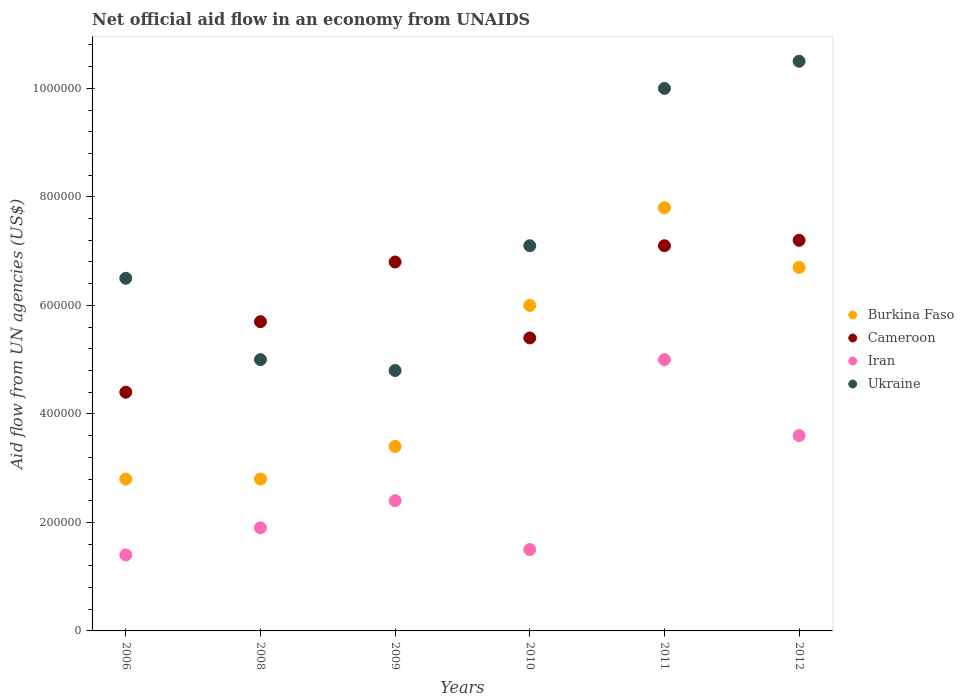Is the number of dotlines equal to the number of legend labels?
Your response must be concise. Yes. Across all years, what is the maximum net official aid flow in Iran?
Offer a terse response. 5.00e+05. Across all years, what is the minimum net official aid flow in Burkina Faso?
Provide a succinct answer. 2.80e+05. In which year was the net official aid flow in Ukraine minimum?
Your answer should be compact. 2009. What is the total net official aid flow in Ukraine in the graph?
Your answer should be compact. 4.39e+06. What is the difference between the net official aid flow in Cameroon in 2006 and that in 2011?
Offer a terse response. -2.70e+05. What is the difference between the net official aid flow in Iran in 2010 and the net official aid flow in Cameroon in 2009?
Your answer should be very brief. -5.30e+05. What is the average net official aid flow in Iran per year?
Provide a short and direct response. 2.63e+05. In the year 2012, what is the difference between the net official aid flow in Burkina Faso and net official aid flow in Ukraine?
Keep it short and to the point. -3.80e+05. In how many years, is the net official aid flow in Burkina Faso greater than 720000 US$?
Give a very brief answer. 1. What is the ratio of the net official aid flow in Iran in 2009 to that in 2011?
Ensure brevity in your answer.  0.48. Is the net official aid flow in Iran in 2009 less than that in 2012?
Your response must be concise. Yes. What is the difference between the highest and the second highest net official aid flow in Ukraine?
Provide a short and direct response. 5.00e+04. What is the difference between the highest and the lowest net official aid flow in Burkina Faso?
Offer a very short reply. 5.00e+05. In how many years, is the net official aid flow in Iran greater than the average net official aid flow in Iran taken over all years?
Your answer should be compact. 2. Is the sum of the net official aid flow in Burkina Faso in 2008 and 2009 greater than the maximum net official aid flow in Iran across all years?
Give a very brief answer. Yes. Is it the case that in every year, the sum of the net official aid flow in Ukraine and net official aid flow in Burkina Faso  is greater than the net official aid flow in Iran?
Your answer should be compact. Yes. Is the net official aid flow in Burkina Faso strictly greater than the net official aid flow in Ukraine over the years?
Your answer should be compact. No. Is the net official aid flow in Iran strictly less than the net official aid flow in Ukraine over the years?
Provide a succinct answer. Yes. How many dotlines are there?
Provide a short and direct response. 4. Are the values on the major ticks of Y-axis written in scientific E-notation?
Offer a terse response. No. Does the graph contain any zero values?
Provide a succinct answer. No. Does the graph contain grids?
Your answer should be compact. No. How many legend labels are there?
Ensure brevity in your answer.  4. How are the legend labels stacked?
Ensure brevity in your answer.  Vertical. What is the title of the graph?
Give a very brief answer. Net official aid flow in an economy from UNAIDS. What is the label or title of the Y-axis?
Offer a very short reply. Aid flow from UN agencies (US$). What is the Aid flow from UN agencies (US$) in Cameroon in 2006?
Offer a terse response. 4.40e+05. What is the Aid flow from UN agencies (US$) in Ukraine in 2006?
Your answer should be very brief. 6.50e+05. What is the Aid flow from UN agencies (US$) of Burkina Faso in 2008?
Offer a very short reply. 2.80e+05. What is the Aid flow from UN agencies (US$) in Cameroon in 2008?
Provide a short and direct response. 5.70e+05. What is the Aid flow from UN agencies (US$) of Ukraine in 2008?
Offer a very short reply. 5.00e+05. What is the Aid flow from UN agencies (US$) of Burkina Faso in 2009?
Offer a very short reply. 3.40e+05. What is the Aid flow from UN agencies (US$) of Cameroon in 2009?
Provide a succinct answer. 6.80e+05. What is the Aid flow from UN agencies (US$) of Iran in 2009?
Your response must be concise. 2.40e+05. What is the Aid flow from UN agencies (US$) in Ukraine in 2009?
Offer a terse response. 4.80e+05. What is the Aid flow from UN agencies (US$) of Cameroon in 2010?
Your response must be concise. 5.40e+05. What is the Aid flow from UN agencies (US$) of Ukraine in 2010?
Ensure brevity in your answer.  7.10e+05. What is the Aid flow from UN agencies (US$) of Burkina Faso in 2011?
Make the answer very short. 7.80e+05. What is the Aid flow from UN agencies (US$) of Cameroon in 2011?
Ensure brevity in your answer.  7.10e+05. What is the Aid flow from UN agencies (US$) in Iran in 2011?
Keep it short and to the point. 5.00e+05. What is the Aid flow from UN agencies (US$) of Ukraine in 2011?
Offer a very short reply. 1.00e+06. What is the Aid flow from UN agencies (US$) in Burkina Faso in 2012?
Offer a terse response. 6.70e+05. What is the Aid flow from UN agencies (US$) in Cameroon in 2012?
Provide a succinct answer. 7.20e+05. What is the Aid flow from UN agencies (US$) in Ukraine in 2012?
Provide a succinct answer. 1.05e+06. Across all years, what is the maximum Aid flow from UN agencies (US$) in Burkina Faso?
Your response must be concise. 7.80e+05. Across all years, what is the maximum Aid flow from UN agencies (US$) of Cameroon?
Your answer should be very brief. 7.20e+05. Across all years, what is the maximum Aid flow from UN agencies (US$) in Ukraine?
Ensure brevity in your answer.  1.05e+06. Across all years, what is the minimum Aid flow from UN agencies (US$) of Iran?
Offer a terse response. 1.40e+05. Across all years, what is the minimum Aid flow from UN agencies (US$) in Ukraine?
Offer a terse response. 4.80e+05. What is the total Aid flow from UN agencies (US$) of Burkina Faso in the graph?
Provide a succinct answer. 2.95e+06. What is the total Aid flow from UN agencies (US$) of Cameroon in the graph?
Offer a very short reply. 3.66e+06. What is the total Aid flow from UN agencies (US$) in Iran in the graph?
Offer a very short reply. 1.58e+06. What is the total Aid flow from UN agencies (US$) in Ukraine in the graph?
Your answer should be compact. 4.39e+06. What is the difference between the Aid flow from UN agencies (US$) of Burkina Faso in 2006 and that in 2008?
Offer a terse response. 0. What is the difference between the Aid flow from UN agencies (US$) in Cameroon in 2006 and that in 2008?
Offer a terse response. -1.30e+05. What is the difference between the Aid flow from UN agencies (US$) of Ukraine in 2006 and that in 2008?
Ensure brevity in your answer.  1.50e+05. What is the difference between the Aid flow from UN agencies (US$) of Burkina Faso in 2006 and that in 2009?
Your response must be concise. -6.00e+04. What is the difference between the Aid flow from UN agencies (US$) of Burkina Faso in 2006 and that in 2010?
Your answer should be very brief. -3.20e+05. What is the difference between the Aid flow from UN agencies (US$) of Cameroon in 2006 and that in 2010?
Offer a terse response. -1.00e+05. What is the difference between the Aid flow from UN agencies (US$) in Iran in 2006 and that in 2010?
Offer a terse response. -10000. What is the difference between the Aid flow from UN agencies (US$) in Burkina Faso in 2006 and that in 2011?
Make the answer very short. -5.00e+05. What is the difference between the Aid flow from UN agencies (US$) of Iran in 2006 and that in 2011?
Your answer should be very brief. -3.60e+05. What is the difference between the Aid flow from UN agencies (US$) of Ukraine in 2006 and that in 2011?
Give a very brief answer. -3.50e+05. What is the difference between the Aid flow from UN agencies (US$) of Burkina Faso in 2006 and that in 2012?
Your answer should be compact. -3.90e+05. What is the difference between the Aid flow from UN agencies (US$) in Cameroon in 2006 and that in 2012?
Your answer should be very brief. -2.80e+05. What is the difference between the Aid flow from UN agencies (US$) in Ukraine in 2006 and that in 2012?
Offer a very short reply. -4.00e+05. What is the difference between the Aid flow from UN agencies (US$) of Burkina Faso in 2008 and that in 2009?
Your response must be concise. -6.00e+04. What is the difference between the Aid flow from UN agencies (US$) of Iran in 2008 and that in 2009?
Offer a very short reply. -5.00e+04. What is the difference between the Aid flow from UN agencies (US$) in Burkina Faso in 2008 and that in 2010?
Keep it short and to the point. -3.20e+05. What is the difference between the Aid flow from UN agencies (US$) of Iran in 2008 and that in 2010?
Provide a succinct answer. 4.00e+04. What is the difference between the Aid flow from UN agencies (US$) of Ukraine in 2008 and that in 2010?
Make the answer very short. -2.10e+05. What is the difference between the Aid flow from UN agencies (US$) in Burkina Faso in 2008 and that in 2011?
Your response must be concise. -5.00e+05. What is the difference between the Aid flow from UN agencies (US$) in Cameroon in 2008 and that in 2011?
Make the answer very short. -1.40e+05. What is the difference between the Aid flow from UN agencies (US$) in Iran in 2008 and that in 2011?
Provide a succinct answer. -3.10e+05. What is the difference between the Aid flow from UN agencies (US$) of Ukraine in 2008 and that in 2011?
Give a very brief answer. -5.00e+05. What is the difference between the Aid flow from UN agencies (US$) in Burkina Faso in 2008 and that in 2012?
Provide a short and direct response. -3.90e+05. What is the difference between the Aid flow from UN agencies (US$) in Cameroon in 2008 and that in 2012?
Your answer should be very brief. -1.50e+05. What is the difference between the Aid flow from UN agencies (US$) of Iran in 2008 and that in 2012?
Keep it short and to the point. -1.70e+05. What is the difference between the Aid flow from UN agencies (US$) in Ukraine in 2008 and that in 2012?
Provide a succinct answer. -5.50e+05. What is the difference between the Aid flow from UN agencies (US$) in Burkina Faso in 2009 and that in 2010?
Give a very brief answer. -2.60e+05. What is the difference between the Aid flow from UN agencies (US$) of Cameroon in 2009 and that in 2010?
Keep it short and to the point. 1.40e+05. What is the difference between the Aid flow from UN agencies (US$) in Burkina Faso in 2009 and that in 2011?
Give a very brief answer. -4.40e+05. What is the difference between the Aid flow from UN agencies (US$) in Cameroon in 2009 and that in 2011?
Ensure brevity in your answer.  -3.00e+04. What is the difference between the Aid flow from UN agencies (US$) of Ukraine in 2009 and that in 2011?
Give a very brief answer. -5.20e+05. What is the difference between the Aid flow from UN agencies (US$) in Burkina Faso in 2009 and that in 2012?
Provide a short and direct response. -3.30e+05. What is the difference between the Aid flow from UN agencies (US$) of Iran in 2009 and that in 2012?
Your answer should be very brief. -1.20e+05. What is the difference between the Aid flow from UN agencies (US$) in Ukraine in 2009 and that in 2012?
Keep it short and to the point. -5.70e+05. What is the difference between the Aid flow from UN agencies (US$) of Cameroon in 2010 and that in 2011?
Give a very brief answer. -1.70e+05. What is the difference between the Aid flow from UN agencies (US$) in Iran in 2010 and that in 2011?
Ensure brevity in your answer.  -3.50e+05. What is the difference between the Aid flow from UN agencies (US$) in Burkina Faso in 2010 and that in 2012?
Your answer should be compact. -7.00e+04. What is the difference between the Aid flow from UN agencies (US$) of Ukraine in 2010 and that in 2012?
Offer a very short reply. -3.40e+05. What is the difference between the Aid flow from UN agencies (US$) of Cameroon in 2011 and that in 2012?
Your answer should be very brief. -10000. What is the difference between the Aid flow from UN agencies (US$) in Iran in 2011 and that in 2012?
Provide a succinct answer. 1.40e+05. What is the difference between the Aid flow from UN agencies (US$) in Burkina Faso in 2006 and the Aid flow from UN agencies (US$) in Iran in 2008?
Offer a terse response. 9.00e+04. What is the difference between the Aid flow from UN agencies (US$) of Cameroon in 2006 and the Aid flow from UN agencies (US$) of Iran in 2008?
Offer a terse response. 2.50e+05. What is the difference between the Aid flow from UN agencies (US$) in Cameroon in 2006 and the Aid flow from UN agencies (US$) in Ukraine in 2008?
Offer a terse response. -6.00e+04. What is the difference between the Aid flow from UN agencies (US$) in Iran in 2006 and the Aid flow from UN agencies (US$) in Ukraine in 2008?
Keep it short and to the point. -3.60e+05. What is the difference between the Aid flow from UN agencies (US$) in Burkina Faso in 2006 and the Aid flow from UN agencies (US$) in Cameroon in 2009?
Provide a short and direct response. -4.00e+05. What is the difference between the Aid flow from UN agencies (US$) in Burkina Faso in 2006 and the Aid flow from UN agencies (US$) in Ukraine in 2009?
Offer a terse response. -2.00e+05. What is the difference between the Aid flow from UN agencies (US$) in Cameroon in 2006 and the Aid flow from UN agencies (US$) in Ukraine in 2009?
Provide a succinct answer. -4.00e+04. What is the difference between the Aid flow from UN agencies (US$) of Iran in 2006 and the Aid flow from UN agencies (US$) of Ukraine in 2009?
Provide a succinct answer. -3.40e+05. What is the difference between the Aid flow from UN agencies (US$) in Burkina Faso in 2006 and the Aid flow from UN agencies (US$) in Ukraine in 2010?
Ensure brevity in your answer.  -4.30e+05. What is the difference between the Aid flow from UN agencies (US$) of Cameroon in 2006 and the Aid flow from UN agencies (US$) of Ukraine in 2010?
Offer a very short reply. -2.70e+05. What is the difference between the Aid flow from UN agencies (US$) of Iran in 2006 and the Aid flow from UN agencies (US$) of Ukraine in 2010?
Make the answer very short. -5.70e+05. What is the difference between the Aid flow from UN agencies (US$) of Burkina Faso in 2006 and the Aid flow from UN agencies (US$) of Cameroon in 2011?
Your response must be concise. -4.30e+05. What is the difference between the Aid flow from UN agencies (US$) in Burkina Faso in 2006 and the Aid flow from UN agencies (US$) in Iran in 2011?
Your answer should be compact. -2.20e+05. What is the difference between the Aid flow from UN agencies (US$) of Burkina Faso in 2006 and the Aid flow from UN agencies (US$) of Ukraine in 2011?
Your answer should be very brief. -7.20e+05. What is the difference between the Aid flow from UN agencies (US$) in Cameroon in 2006 and the Aid flow from UN agencies (US$) in Iran in 2011?
Your answer should be very brief. -6.00e+04. What is the difference between the Aid flow from UN agencies (US$) of Cameroon in 2006 and the Aid flow from UN agencies (US$) of Ukraine in 2011?
Keep it short and to the point. -5.60e+05. What is the difference between the Aid flow from UN agencies (US$) of Iran in 2006 and the Aid flow from UN agencies (US$) of Ukraine in 2011?
Provide a succinct answer. -8.60e+05. What is the difference between the Aid flow from UN agencies (US$) in Burkina Faso in 2006 and the Aid flow from UN agencies (US$) in Cameroon in 2012?
Your response must be concise. -4.40e+05. What is the difference between the Aid flow from UN agencies (US$) in Burkina Faso in 2006 and the Aid flow from UN agencies (US$) in Ukraine in 2012?
Provide a short and direct response. -7.70e+05. What is the difference between the Aid flow from UN agencies (US$) in Cameroon in 2006 and the Aid flow from UN agencies (US$) in Iran in 2012?
Your answer should be compact. 8.00e+04. What is the difference between the Aid flow from UN agencies (US$) in Cameroon in 2006 and the Aid flow from UN agencies (US$) in Ukraine in 2012?
Offer a terse response. -6.10e+05. What is the difference between the Aid flow from UN agencies (US$) of Iran in 2006 and the Aid flow from UN agencies (US$) of Ukraine in 2012?
Provide a succinct answer. -9.10e+05. What is the difference between the Aid flow from UN agencies (US$) of Burkina Faso in 2008 and the Aid flow from UN agencies (US$) of Cameroon in 2009?
Offer a very short reply. -4.00e+05. What is the difference between the Aid flow from UN agencies (US$) in Burkina Faso in 2008 and the Aid flow from UN agencies (US$) in Ukraine in 2009?
Provide a short and direct response. -2.00e+05. What is the difference between the Aid flow from UN agencies (US$) of Cameroon in 2008 and the Aid flow from UN agencies (US$) of Ukraine in 2009?
Provide a succinct answer. 9.00e+04. What is the difference between the Aid flow from UN agencies (US$) of Burkina Faso in 2008 and the Aid flow from UN agencies (US$) of Ukraine in 2010?
Your response must be concise. -4.30e+05. What is the difference between the Aid flow from UN agencies (US$) of Iran in 2008 and the Aid flow from UN agencies (US$) of Ukraine in 2010?
Your answer should be compact. -5.20e+05. What is the difference between the Aid flow from UN agencies (US$) in Burkina Faso in 2008 and the Aid flow from UN agencies (US$) in Cameroon in 2011?
Your answer should be compact. -4.30e+05. What is the difference between the Aid flow from UN agencies (US$) of Burkina Faso in 2008 and the Aid flow from UN agencies (US$) of Iran in 2011?
Give a very brief answer. -2.20e+05. What is the difference between the Aid flow from UN agencies (US$) in Burkina Faso in 2008 and the Aid flow from UN agencies (US$) in Ukraine in 2011?
Your response must be concise. -7.20e+05. What is the difference between the Aid flow from UN agencies (US$) of Cameroon in 2008 and the Aid flow from UN agencies (US$) of Iran in 2011?
Offer a terse response. 7.00e+04. What is the difference between the Aid flow from UN agencies (US$) of Cameroon in 2008 and the Aid flow from UN agencies (US$) of Ukraine in 2011?
Your response must be concise. -4.30e+05. What is the difference between the Aid flow from UN agencies (US$) in Iran in 2008 and the Aid flow from UN agencies (US$) in Ukraine in 2011?
Ensure brevity in your answer.  -8.10e+05. What is the difference between the Aid flow from UN agencies (US$) of Burkina Faso in 2008 and the Aid flow from UN agencies (US$) of Cameroon in 2012?
Make the answer very short. -4.40e+05. What is the difference between the Aid flow from UN agencies (US$) in Burkina Faso in 2008 and the Aid flow from UN agencies (US$) in Ukraine in 2012?
Ensure brevity in your answer.  -7.70e+05. What is the difference between the Aid flow from UN agencies (US$) in Cameroon in 2008 and the Aid flow from UN agencies (US$) in Ukraine in 2012?
Provide a short and direct response. -4.80e+05. What is the difference between the Aid flow from UN agencies (US$) of Iran in 2008 and the Aid flow from UN agencies (US$) of Ukraine in 2012?
Keep it short and to the point. -8.60e+05. What is the difference between the Aid flow from UN agencies (US$) of Burkina Faso in 2009 and the Aid flow from UN agencies (US$) of Cameroon in 2010?
Your answer should be very brief. -2.00e+05. What is the difference between the Aid flow from UN agencies (US$) of Burkina Faso in 2009 and the Aid flow from UN agencies (US$) of Iran in 2010?
Give a very brief answer. 1.90e+05. What is the difference between the Aid flow from UN agencies (US$) in Burkina Faso in 2009 and the Aid flow from UN agencies (US$) in Ukraine in 2010?
Your answer should be compact. -3.70e+05. What is the difference between the Aid flow from UN agencies (US$) in Cameroon in 2009 and the Aid flow from UN agencies (US$) in Iran in 2010?
Give a very brief answer. 5.30e+05. What is the difference between the Aid flow from UN agencies (US$) of Iran in 2009 and the Aid flow from UN agencies (US$) of Ukraine in 2010?
Ensure brevity in your answer.  -4.70e+05. What is the difference between the Aid flow from UN agencies (US$) of Burkina Faso in 2009 and the Aid flow from UN agencies (US$) of Cameroon in 2011?
Offer a very short reply. -3.70e+05. What is the difference between the Aid flow from UN agencies (US$) in Burkina Faso in 2009 and the Aid flow from UN agencies (US$) in Iran in 2011?
Your answer should be compact. -1.60e+05. What is the difference between the Aid flow from UN agencies (US$) of Burkina Faso in 2009 and the Aid flow from UN agencies (US$) of Ukraine in 2011?
Your answer should be very brief. -6.60e+05. What is the difference between the Aid flow from UN agencies (US$) of Cameroon in 2009 and the Aid flow from UN agencies (US$) of Ukraine in 2011?
Ensure brevity in your answer.  -3.20e+05. What is the difference between the Aid flow from UN agencies (US$) of Iran in 2009 and the Aid flow from UN agencies (US$) of Ukraine in 2011?
Provide a succinct answer. -7.60e+05. What is the difference between the Aid flow from UN agencies (US$) of Burkina Faso in 2009 and the Aid flow from UN agencies (US$) of Cameroon in 2012?
Provide a succinct answer. -3.80e+05. What is the difference between the Aid flow from UN agencies (US$) of Burkina Faso in 2009 and the Aid flow from UN agencies (US$) of Ukraine in 2012?
Your answer should be very brief. -7.10e+05. What is the difference between the Aid flow from UN agencies (US$) in Cameroon in 2009 and the Aid flow from UN agencies (US$) in Iran in 2012?
Ensure brevity in your answer.  3.20e+05. What is the difference between the Aid flow from UN agencies (US$) of Cameroon in 2009 and the Aid flow from UN agencies (US$) of Ukraine in 2012?
Offer a terse response. -3.70e+05. What is the difference between the Aid flow from UN agencies (US$) of Iran in 2009 and the Aid flow from UN agencies (US$) of Ukraine in 2012?
Provide a short and direct response. -8.10e+05. What is the difference between the Aid flow from UN agencies (US$) of Burkina Faso in 2010 and the Aid flow from UN agencies (US$) of Ukraine in 2011?
Offer a very short reply. -4.00e+05. What is the difference between the Aid flow from UN agencies (US$) in Cameroon in 2010 and the Aid flow from UN agencies (US$) in Iran in 2011?
Ensure brevity in your answer.  4.00e+04. What is the difference between the Aid flow from UN agencies (US$) in Cameroon in 2010 and the Aid flow from UN agencies (US$) in Ukraine in 2011?
Provide a succinct answer. -4.60e+05. What is the difference between the Aid flow from UN agencies (US$) of Iran in 2010 and the Aid flow from UN agencies (US$) of Ukraine in 2011?
Offer a very short reply. -8.50e+05. What is the difference between the Aid flow from UN agencies (US$) of Burkina Faso in 2010 and the Aid flow from UN agencies (US$) of Cameroon in 2012?
Your response must be concise. -1.20e+05. What is the difference between the Aid flow from UN agencies (US$) in Burkina Faso in 2010 and the Aid flow from UN agencies (US$) in Ukraine in 2012?
Your response must be concise. -4.50e+05. What is the difference between the Aid flow from UN agencies (US$) in Cameroon in 2010 and the Aid flow from UN agencies (US$) in Iran in 2012?
Offer a terse response. 1.80e+05. What is the difference between the Aid flow from UN agencies (US$) in Cameroon in 2010 and the Aid flow from UN agencies (US$) in Ukraine in 2012?
Keep it short and to the point. -5.10e+05. What is the difference between the Aid flow from UN agencies (US$) in Iran in 2010 and the Aid flow from UN agencies (US$) in Ukraine in 2012?
Offer a terse response. -9.00e+05. What is the difference between the Aid flow from UN agencies (US$) of Burkina Faso in 2011 and the Aid flow from UN agencies (US$) of Cameroon in 2012?
Your response must be concise. 6.00e+04. What is the difference between the Aid flow from UN agencies (US$) in Burkina Faso in 2011 and the Aid flow from UN agencies (US$) in Ukraine in 2012?
Make the answer very short. -2.70e+05. What is the difference between the Aid flow from UN agencies (US$) in Iran in 2011 and the Aid flow from UN agencies (US$) in Ukraine in 2012?
Ensure brevity in your answer.  -5.50e+05. What is the average Aid flow from UN agencies (US$) of Burkina Faso per year?
Your answer should be compact. 4.92e+05. What is the average Aid flow from UN agencies (US$) of Iran per year?
Your answer should be very brief. 2.63e+05. What is the average Aid flow from UN agencies (US$) in Ukraine per year?
Offer a terse response. 7.32e+05. In the year 2006, what is the difference between the Aid flow from UN agencies (US$) of Burkina Faso and Aid flow from UN agencies (US$) of Cameroon?
Provide a succinct answer. -1.60e+05. In the year 2006, what is the difference between the Aid flow from UN agencies (US$) in Burkina Faso and Aid flow from UN agencies (US$) in Ukraine?
Offer a terse response. -3.70e+05. In the year 2006, what is the difference between the Aid flow from UN agencies (US$) of Cameroon and Aid flow from UN agencies (US$) of Ukraine?
Your answer should be very brief. -2.10e+05. In the year 2006, what is the difference between the Aid flow from UN agencies (US$) in Iran and Aid flow from UN agencies (US$) in Ukraine?
Keep it short and to the point. -5.10e+05. In the year 2008, what is the difference between the Aid flow from UN agencies (US$) in Iran and Aid flow from UN agencies (US$) in Ukraine?
Your answer should be compact. -3.10e+05. In the year 2009, what is the difference between the Aid flow from UN agencies (US$) of Burkina Faso and Aid flow from UN agencies (US$) of Cameroon?
Provide a short and direct response. -3.40e+05. In the year 2009, what is the difference between the Aid flow from UN agencies (US$) of Cameroon and Aid flow from UN agencies (US$) of Iran?
Provide a succinct answer. 4.40e+05. In the year 2009, what is the difference between the Aid flow from UN agencies (US$) in Iran and Aid flow from UN agencies (US$) in Ukraine?
Give a very brief answer. -2.40e+05. In the year 2010, what is the difference between the Aid flow from UN agencies (US$) of Cameroon and Aid flow from UN agencies (US$) of Iran?
Your answer should be compact. 3.90e+05. In the year 2010, what is the difference between the Aid flow from UN agencies (US$) in Iran and Aid flow from UN agencies (US$) in Ukraine?
Your response must be concise. -5.60e+05. In the year 2011, what is the difference between the Aid flow from UN agencies (US$) in Cameroon and Aid flow from UN agencies (US$) in Iran?
Give a very brief answer. 2.10e+05. In the year 2011, what is the difference between the Aid flow from UN agencies (US$) in Iran and Aid flow from UN agencies (US$) in Ukraine?
Make the answer very short. -5.00e+05. In the year 2012, what is the difference between the Aid flow from UN agencies (US$) of Burkina Faso and Aid flow from UN agencies (US$) of Ukraine?
Your response must be concise. -3.80e+05. In the year 2012, what is the difference between the Aid flow from UN agencies (US$) in Cameroon and Aid flow from UN agencies (US$) in Iran?
Your answer should be compact. 3.60e+05. In the year 2012, what is the difference between the Aid flow from UN agencies (US$) of Cameroon and Aid flow from UN agencies (US$) of Ukraine?
Provide a succinct answer. -3.30e+05. In the year 2012, what is the difference between the Aid flow from UN agencies (US$) in Iran and Aid flow from UN agencies (US$) in Ukraine?
Your answer should be very brief. -6.90e+05. What is the ratio of the Aid flow from UN agencies (US$) of Cameroon in 2006 to that in 2008?
Your answer should be very brief. 0.77. What is the ratio of the Aid flow from UN agencies (US$) in Iran in 2006 to that in 2008?
Offer a very short reply. 0.74. What is the ratio of the Aid flow from UN agencies (US$) in Burkina Faso in 2006 to that in 2009?
Offer a very short reply. 0.82. What is the ratio of the Aid flow from UN agencies (US$) in Cameroon in 2006 to that in 2009?
Make the answer very short. 0.65. What is the ratio of the Aid flow from UN agencies (US$) of Iran in 2006 to that in 2009?
Offer a terse response. 0.58. What is the ratio of the Aid flow from UN agencies (US$) of Ukraine in 2006 to that in 2009?
Your answer should be compact. 1.35. What is the ratio of the Aid flow from UN agencies (US$) of Burkina Faso in 2006 to that in 2010?
Give a very brief answer. 0.47. What is the ratio of the Aid flow from UN agencies (US$) of Cameroon in 2006 to that in 2010?
Offer a very short reply. 0.81. What is the ratio of the Aid flow from UN agencies (US$) in Iran in 2006 to that in 2010?
Offer a very short reply. 0.93. What is the ratio of the Aid flow from UN agencies (US$) in Ukraine in 2006 to that in 2010?
Offer a terse response. 0.92. What is the ratio of the Aid flow from UN agencies (US$) of Burkina Faso in 2006 to that in 2011?
Keep it short and to the point. 0.36. What is the ratio of the Aid flow from UN agencies (US$) of Cameroon in 2006 to that in 2011?
Your answer should be very brief. 0.62. What is the ratio of the Aid flow from UN agencies (US$) in Iran in 2006 to that in 2011?
Make the answer very short. 0.28. What is the ratio of the Aid flow from UN agencies (US$) of Ukraine in 2006 to that in 2011?
Offer a terse response. 0.65. What is the ratio of the Aid flow from UN agencies (US$) in Burkina Faso in 2006 to that in 2012?
Make the answer very short. 0.42. What is the ratio of the Aid flow from UN agencies (US$) in Cameroon in 2006 to that in 2012?
Your response must be concise. 0.61. What is the ratio of the Aid flow from UN agencies (US$) in Iran in 2006 to that in 2012?
Your answer should be compact. 0.39. What is the ratio of the Aid flow from UN agencies (US$) in Ukraine in 2006 to that in 2012?
Provide a short and direct response. 0.62. What is the ratio of the Aid flow from UN agencies (US$) in Burkina Faso in 2008 to that in 2009?
Give a very brief answer. 0.82. What is the ratio of the Aid flow from UN agencies (US$) of Cameroon in 2008 to that in 2009?
Ensure brevity in your answer.  0.84. What is the ratio of the Aid flow from UN agencies (US$) in Iran in 2008 to that in 2009?
Make the answer very short. 0.79. What is the ratio of the Aid flow from UN agencies (US$) in Ukraine in 2008 to that in 2009?
Offer a very short reply. 1.04. What is the ratio of the Aid flow from UN agencies (US$) in Burkina Faso in 2008 to that in 2010?
Your answer should be compact. 0.47. What is the ratio of the Aid flow from UN agencies (US$) in Cameroon in 2008 to that in 2010?
Your answer should be very brief. 1.06. What is the ratio of the Aid flow from UN agencies (US$) in Iran in 2008 to that in 2010?
Give a very brief answer. 1.27. What is the ratio of the Aid flow from UN agencies (US$) in Ukraine in 2008 to that in 2010?
Give a very brief answer. 0.7. What is the ratio of the Aid flow from UN agencies (US$) in Burkina Faso in 2008 to that in 2011?
Give a very brief answer. 0.36. What is the ratio of the Aid flow from UN agencies (US$) of Cameroon in 2008 to that in 2011?
Provide a short and direct response. 0.8. What is the ratio of the Aid flow from UN agencies (US$) of Iran in 2008 to that in 2011?
Offer a very short reply. 0.38. What is the ratio of the Aid flow from UN agencies (US$) in Ukraine in 2008 to that in 2011?
Keep it short and to the point. 0.5. What is the ratio of the Aid flow from UN agencies (US$) of Burkina Faso in 2008 to that in 2012?
Offer a terse response. 0.42. What is the ratio of the Aid flow from UN agencies (US$) in Cameroon in 2008 to that in 2012?
Give a very brief answer. 0.79. What is the ratio of the Aid flow from UN agencies (US$) in Iran in 2008 to that in 2012?
Offer a terse response. 0.53. What is the ratio of the Aid flow from UN agencies (US$) in Ukraine in 2008 to that in 2012?
Offer a terse response. 0.48. What is the ratio of the Aid flow from UN agencies (US$) in Burkina Faso in 2009 to that in 2010?
Provide a succinct answer. 0.57. What is the ratio of the Aid flow from UN agencies (US$) in Cameroon in 2009 to that in 2010?
Give a very brief answer. 1.26. What is the ratio of the Aid flow from UN agencies (US$) in Iran in 2009 to that in 2010?
Offer a very short reply. 1.6. What is the ratio of the Aid flow from UN agencies (US$) in Ukraine in 2009 to that in 2010?
Your answer should be compact. 0.68. What is the ratio of the Aid flow from UN agencies (US$) in Burkina Faso in 2009 to that in 2011?
Your response must be concise. 0.44. What is the ratio of the Aid flow from UN agencies (US$) in Cameroon in 2009 to that in 2011?
Your answer should be very brief. 0.96. What is the ratio of the Aid flow from UN agencies (US$) of Iran in 2009 to that in 2011?
Provide a succinct answer. 0.48. What is the ratio of the Aid flow from UN agencies (US$) in Ukraine in 2009 to that in 2011?
Make the answer very short. 0.48. What is the ratio of the Aid flow from UN agencies (US$) of Burkina Faso in 2009 to that in 2012?
Make the answer very short. 0.51. What is the ratio of the Aid flow from UN agencies (US$) in Ukraine in 2009 to that in 2012?
Provide a short and direct response. 0.46. What is the ratio of the Aid flow from UN agencies (US$) in Burkina Faso in 2010 to that in 2011?
Your response must be concise. 0.77. What is the ratio of the Aid flow from UN agencies (US$) of Cameroon in 2010 to that in 2011?
Keep it short and to the point. 0.76. What is the ratio of the Aid flow from UN agencies (US$) of Iran in 2010 to that in 2011?
Provide a succinct answer. 0.3. What is the ratio of the Aid flow from UN agencies (US$) of Ukraine in 2010 to that in 2011?
Offer a very short reply. 0.71. What is the ratio of the Aid flow from UN agencies (US$) in Burkina Faso in 2010 to that in 2012?
Your answer should be compact. 0.9. What is the ratio of the Aid flow from UN agencies (US$) of Iran in 2010 to that in 2012?
Provide a succinct answer. 0.42. What is the ratio of the Aid flow from UN agencies (US$) of Ukraine in 2010 to that in 2012?
Your answer should be very brief. 0.68. What is the ratio of the Aid flow from UN agencies (US$) of Burkina Faso in 2011 to that in 2012?
Your response must be concise. 1.16. What is the ratio of the Aid flow from UN agencies (US$) of Cameroon in 2011 to that in 2012?
Provide a short and direct response. 0.99. What is the ratio of the Aid flow from UN agencies (US$) in Iran in 2011 to that in 2012?
Your answer should be compact. 1.39. What is the difference between the highest and the second highest Aid flow from UN agencies (US$) of Burkina Faso?
Offer a very short reply. 1.10e+05. What is the difference between the highest and the second highest Aid flow from UN agencies (US$) of Iran?
Provide a short and direct response. 1.40e+05. What is the difference between the highest and the second highest Aid flow from UN agencies (US$) in Ukraine?
Your answer should be compact. 5.00e+04. What is the difference between the highest and the lowest Aid flow from UN agencies (US$) in Cameroon?
Your response must be concise. 2.80e+05. What is the difference between the highest and the lowest Aid flow from UN agencies (US$) in Iran?
Your response must be concise. 3.60e+05. What is the difference between the highest and the lowest Aid flow from UN agencies (US$) in Ukraine?
Provide a short and direct response. 5.70e+05. 